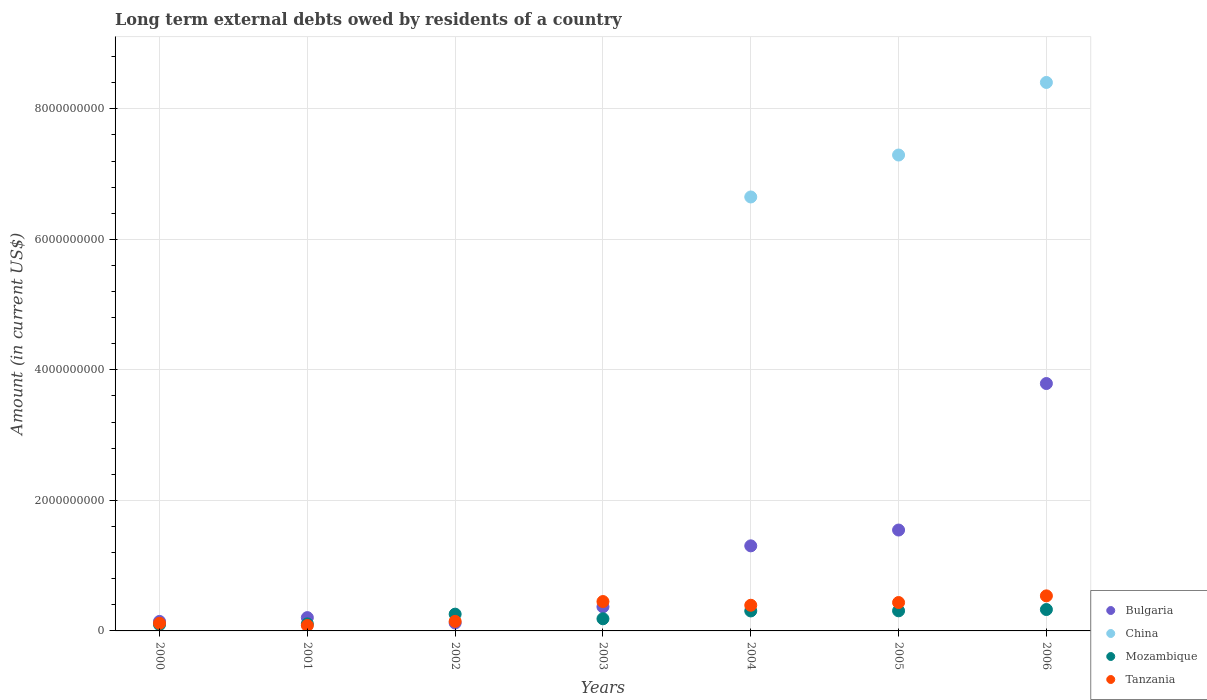How many different coloured dotlines are there?
Offer a terse response. 4. What is the amount of long-term external debts owed by residents in China in 2000?
Give a very brief answer. 0. Across all years, what is the maximum amount of long-term external debts owed by residents in Bulgaria?
Your response must be concise. 3.79e+09. Across all years, what is the minimum amount of long-term external debts owed by residents in Tanzania?
Your answer should be very brief. 8.26e+07. What is the total amount of long-term external debts owed by residents in Tanzania in the graph?
Offer a very short reply. 2.16e+09. What is the difference between the amount of long-term external debts owed by residents in Tanzania in 2002 and that in 2003?
Give a very brief answer. -3.04e+08. What is the difference between the amount of long-term external debts owed by residents in Bulgaria in 2006 and the amount of long-term external debts owed by residents in Mozambique in 2005?
Offer a very short reply. 3.48e+09. What is the average amount of long-term external debts owed by residents in Bulgaria per year?
Your answer should be very brief. 1.07e+09. In the year 2001, what is the difference between the amount of long-term external debts owed by residents in Tanzania and amount of long-term external debts owed by residents in Mozambique?
Your response must be concise. -2.53e+07. What is the ratio of the amount of long-term external debts owed by residents in Bulgaria in 2004 to that in 2006?
Your answer should be very brief. 0.34. What is the difference between the highest and the second highest amount of long-term external debts owed by residents in Tanzania?
Offer a very short reply. 8.70e+07. What is the difference between the highest and the lowest amount of long-term external debts owed by residents in Tanzania?
Provide a succinct answer. 4.55e+08. In how many years, is the amount of long-term external debts owed by residents in Tanzania greater than the average amount of long-term external debts owed by residents in Tanzania taken over all years?
Offer a very short reply. 4. Is the sum of the amount of long-term external debts owed by residents in Mozambique in 2001 and 2005 greater than the maximum amount of long-term external debts owed by residents in Bulgaria across all years?
Offer a terse response. No. Is it the case that in every year, the sum of the amount of long-term external debts owed by residents in Mozambique and amount of long-term external debts owed by residents in Bulgaria  is greater than the sum of amount of long-term external debts owed by residents in China and amount of long-term external debts owed by residents in Tanzania?
Give a very brief answer. No. Is it the case that in every year, the sum of the amount of long-term external debts owed by residents in Bulgaria and amount of long-term external debts owed by residents in Tanzania  is greater than the amount of long-term external debts owed by residents in China?
Provide a succinct answer. No. Is the amount of long-term external debts owed by residents in Mozambique strictly greater than the amount of long-term external debts owed by residents in China over the years?
Your answer should be compact. No. Is the amount of long-term external debts owed by residents in Mozambique strictly less than the amount of long-term external debts owed by residents in Bulgaria over the years?
Your answer should be compact. No. How many dotlines are there?
Your response must be concise. 4. How many years are there in the graph?
Offer a very short reply. 7. What is the difference between two consecutive major ticks on the Y-axis?
Provide a succinct answer. 2.00e+09. How are the legend labels stacked?
Keep it short and to the point. Vertical. What is the title of the graph?
Your answer should be very brief. Long term external debts owed by residents of a country. What is the label or title of the X-axis?
Provide a succinct answer. Years. What is the label or title of the Y-axis?
Make the answer very short. Amount (in current US$). What is the Amount (in current US$) of Bulgaria in 2000?
Make the answer very short. 1.45e+08. What is the Amount (in current US$) in Mozambique in 2000?
Your answer should be compact. 9.69e+07. What is the Amount (in current US$) of Tanzania in 2000?
Your answer should be compact. 1.18e+08. What is the Amount (in current US$) of Bulgaria in 2001?
Your answer should be very brief. 2.04e+08. What is the Amount (in current US$) of China in 2001?
Provide a short and direct response. 0. What is the Amount (in current US$) of Mozambique in 2001?
Make the answer very short. 1.08e+08. What is the Amount (in current US$) of Tanzania in 2001?
Keep it short and to the point. 8.26e+07. What is the Amount (in current US$) in Bulgaria in 2002?
Offer a very short reply. 1.21e+08. What is the Amount (in current US$) of Mozambique in 2002?
Keep it short and to the point. 2.57e+08. What is the Amount (in current US$) in Tanzania in 2002?
Keep it short and to the point. 1.46e+08. What is the Amount (in current US$) of Bulgaria in 2003?
Provide a short and direct response. 3.69e+08. What is the Amount (in current US$) of Mozambique in 2003?
Give a very brief answer. 1.86e+08. What is the Amount (in current US$) of Tanzania in 2003?
Offer a terse response. 4.50e+08. What is the Amount (in current US$) of Bulgaria in 2004?
Your answer should be compact. 1.30e+09. What is the Amount (in current US$) in China in 2004?
Give a very brief answer. 6.65e+09. What is the Amount (in current US$) of Mozambique in 2004?
Keep it short and to the point. 3.06e+08. What is the Amount (in current US$) of Tanzania in 2004?
Provide a short and direct response. 3.93e+08. What is the Amount (in current US$) of Bulgaria in 2005?
Make the answer very short. 1.55e+09. What is the Amount (in current US$) of China in 2005?
Your response must be concise. 7.29e+09. What is the Amount (in current US$) in Mozambique in 2005?
Keep it short and to the point. 3.08e+08. What is the Amount (in current US$) in Tanzania in 2005?
Make the answer very short. 4.35e+08. What is the Amount (in current US$) of Bulgaria in 2006?
Keep it short and to the point. 3.79e+09. What is the Amount (in current US$) of China in 2006?
Provide a short and direct response. 8.40e+09. What is the Amount (in current US$) of Mozambique in 2006?
Provide a short and direct response. 3.28e+08. What is the Amount (in current US$) in Tanzania in 2006?
Offer a terse response. 5.37e+08. Across all years, what is the maximum Amount (in current US$) in Bulgaria?
Keep it short and to the point. 3.79e+09. Across all years, what is the maximum Amount (in current US$) in China?
Your answer should be compact. 8.40e+09. Across all years, what is the maximum Amount (in current US$) in Mozambique?
Provide a succinct answer. 3.28e+08. Across all years, what is the maximum Amount (in current US$) in Tanzania?
Provide a succinct answer. 5.37e+08. Across all years, what is the minimum Amount (in current US$) in Bulgaria?
Offer a very short reply. 1.21e+08. Across all years, what is the minimum Amount (in current US$) of Mozambique?
Offer a terse response. 9.69e+07. Across all years, what is the minimum Amount (in current US$) of Tanzania?
Make the answer very short. 8.26e+07. What is the total Amount (in current US$) in Bulgaria in the graph?
Offer a terse response. 7.48e+09. What is the total Amount (in current US$) of China in the graph?
Ensure brevity in your answer.  2.23e+1. What is the total Amount (in current US$) in Mozambique in the graph?
Provide a short and direct response. 1.59e+09. What is the total Amount (in current US$) of Tanzania in the graph?
Your response must be concise. 2.16e+09. What is the difference between the Amount (in current US$) in Bulgaria in 2000 and that in 2001?
Provide a succinct answer. -5.84e+07. What is the difference between the Amount (in current US$) of Mozambique in 2000 and that in 2001?
Give a very brief answer. -1.10e+07. What is the difference between the Amount (in current US$) in Tanzania in 2000 and that in 2001?
Provide a succinct answer. 3.51e+07. What is the difference between the Amount (in current US$) in Bulgaria in 2000 and that in 2002?
Provide a succinct answer. 2.41e+07. What is the difference between the Amount (in current US$) of Mozambique in 2000 and that in 2002?
Provide a succinct answer. -1.60e+08. What is the difference between the Amount (in current US$) of Tanzania in 2000 and that in 2002?
Offer a terse response. -2.85e+07. What is the difference between the Amount (in current US$) of Bulgaria in 2000 and that in 2003?
Your answer should be compact. -2.24e+08. What is the difference between the Amount (in current US$) in Mozambique in 2000 and that in 2003?
Keep it short and to the point. -8.91e+07. What is the difference between the Amount (in current US$) in Tanzania in 2000 and that in 2003?
Your response must be concise. -3.32e+08. What is the difference between the Amount (in current US$) in Bulgaria in 2000 and that in 2004?
Offer a very short reply. -1.16e+09. What is the difference between the Amount (in current US$) of Mozambique in 2000 and that in 2004?
Offer a terse response. -2.09e+08. What is the difference between the Amount (in current US$) of Tanzania in 2000 and that in 2004?
Give a very brief answer. -2.75e+08. What is the difference between the Amount (in current US$) of Bulgaria in 2000 and that in 2005?
Keep it short and to the point. -1.40e+09. What is the difference between the Amount (in current US$) in Mozambique in 2000 and that in 2005?
Ensure brevity in your answer.  -2.11e+08. What is the difference between the Amount (in current US$) of Tanzania in 2000 and that in 2005?
Keep it short and to the point. -3.17e+08. What is the difference between the Amount (in current US$) of Bulgaria in 2000 and that in 2006?
Ensure brevity in your answer.  -3.65e+09. What is the difference between the Amount (in current US$) of Mozambique in 2000 and that in 2006?
Provide a short and direct response. -2.31e+08. What is the difference between the Amount (in current US$) in Tanzania in 2000 and that in 2006?
Your answer should be very brief. -4.19e+08. What is the difference between the Amount (in current US$) of Bulgaria in 2001 and that in 2002?
Offer a terse response. 8.25e+07. What is the difference between the Amount (in current US$) in Mozambique in 2001 and that in 2002?
Make the answer very short. -1.49e+08. What is the difference between the Amount (in current US$) in Tanzania in 2001 and that in 2002?
Give a very brief answer. -6.37e+07. What is the difference between the Amount (in current US$) of Bulgaria in 2001 and that in 2003?
Provide a succinct answer. -1.66e+08. What is the difference between the Amount (in current US$) in Mozambique in 2001 and that in 2003?
Your answer should be compact. -7.81e+07. What is the difference between the Amount (in current US$) in Tanzania in 2001 and that in 2003?
Make the answer very short. -3.68e+08. What is the difference between the Amount (in current US$) of Bulgaria in 2001 and that in 2004?
Keep it short and to the point. -1.10e+09. What is the difference between the Amount (in current US$) of Mozambique in 2001 and that in 2004?
Your answer should be compact. -1.98e+08. What is the difference between the Amount (in current US$) of Tanzania in 2001 and that in 2004?
Keep it short and to the point. -3.11e+08. What is the difference between the Amount (in current US$) in Bulgaria in 2001 and that in 2005?
Keep it short and to the point. -1.34e+09. What is the difference between the Amount (in current US$) of Mozambique in 2001 and that in 2005?
Your answer should be compact. -2.00e+08. What is the difference between the Amount (in current US$) in Tanzania in 2001 and that in 2005?
Your answer should be very brief. -3.52e+08. What is the difference between the Amount (in current US$) in Bulgaria in 2001 and that in 2006?
Make the answer very short. -3.59e+09. What is the difference between the Amount (in current US$) in Mozambique in 2001 and that in 2006?
Provide a short and direct response. -2.20e+08. What is the difference between the Amount (in current US$) of Tanzania in 2001 and that in 2006?
Make the answer very short. -4.55e+08. What is the difference between the Amount (in current US$) in Bulgaria in 2002 and that in 2003?
Make the answer very short. -2.48e+08. What is the difference between the Amount (in current US$) of Mozambique in 2002 and that in 2003?
Your response must be concise. 7.09e+07. What is the difference between the Amount (in current US$) of Tanzania in 2002 and that in 2003?
Give a very brief answer. -3.04e+08. What is the difference between the Amount (in current US$) of Bulgaria in 2002 and that in 2004?
Your answer should be compact. -1.18e+09. What is the difference between the Amount (in current US$) in Mozambique in 2002 and that in 2004?
Give a very brief answer. -4.92e+07. What is the difference between the Amount (in current US$) in Tanzania in 2002 and that in 2004?
Provide a short and direct response. -2.47e+08. What is the difference between the Amount (in current US$) of Bulgaria in 2002 and that in 2005?
Your answer should be compact. -1.42e+09. What is the difference between the Amount (in current US$) in Mozambique in 2002 and that in 2005?
Ensure brevity in your answer.  -5.10e+07. What is the difference between the Amount (in current US$) in Tanzania in 2002 and that in 2005?
Your answer should be very brief. -2.89e+08. What is the difference between the Amount (in current US$) of Bulgaria in 2002 and that in 2006?
Your response must be concise. -3.67e+09. What is the difference between the Amount (in current US$) of Mozambique in 2002 and that in 2006?
Your answer should be compact. -7.09e+07. What is the difference between the Amount (in current US$) in Tanzania in 2002 and that in 2006?
Offer a terse response. -3.91e+08. What is the difference between the Amount (in current US$) in Bulgaria in 2003 and that in 2004?
Keep it short and to the point. -9.34e+08. What is the difference between the Amount (in current US$) of Mozambique in 2003 and that in 2004?
Ensure brevity in your answer.  -1.20e+08. What is the difference between the Amount (in current US$) in Tanzania in 2003 and that in 2004?
Keep it short and to the point. 5.70e+07. What is the difference between the Amount (in current US$) of Bulgaria in 2003 and that in 2005?
Give a very brief answer. -1.18e+09. What is the difference between the Amount (in current US$) of Mozambique in 2003 and that in 2005?
Your answer should be very brief. -1.22e+08. What is the difference between the Amount (in current US$) of Tanzania in 2003 and that in 2005?
Your response must be concise. 1.50e+07. What is the difference between the Amount (in current US$) of Bulgaria in 2003 and that in 2006?
Your answer should be compact. -3.42e+09. What is the difference between the Amount (in current US$) in Mozambique in 2003 and that in 2006?
Make the answer very short. -1.42e+08. What is the difference between the Amount (in current US$) in Tanzania in 2003 and that in 2006?
Ensure brevity in your answer.  -8.70e+07. What is the difference between the Amount (in current US$) of Bulgaria in 2004 and that in 2005?
Offer a terse response. -2.42e+08. What is the difference between the Amount (in current US$) in China in 2004 and that in 2005?
Keep it short and to the point. -6.43e+08. What is the difference between the Amount (in current US$) of Mozambique in 2004 and that in 2005?
Your answer should be compact. -1.89e+06. What is the difference between the Amount (in current US$) in Tanzania in 2004 and that in 2005?
Provide a short and direct response. -4.20e+07. What is the difference between the Amount (in current US$) of Bulgaria in 2004 and that in 2006?
Make the answer very short. -2.49e+09. What is the difference between the Amount (in current US$) in China in 2004 and that in 2006?
Make the answer very short. -1.75e+09. What is the difference between the Amount (in current US$) in Mozambique in 2004 and that in 2006?
Give a very brief answer. -2.17e+07. What is the difference between the Amount (in current US$) of Tanzania in 2004 and that in 2006?
Give a very brief answer. -1.44e+08. What is the difference between the Amount (in current US$) in Bulgaria in 2005 and that in 2006?
Give a very brief answer. -2.24e+09. What is the difference between the Amount (in current US$) in China in 2005 and that in 2006?
Offer a very short reply. -1.11e+09. What is the difference between the Amount (in current US$) of Mozambique in 2005 and that in 2006?
Make the answer very short. -1.98e+07. What is the difference between the Amount (in current US$) of Tanzania in 2005 and that in 2006?
Give a very brief answer. -1.02e+08. What is the difference between the Amount (in current US$) of Bulgaria in 2000 and the Amount (in current US$) of Mozambique in 2001?
Keep it short and to the point. 3.75e+07. What is the difference between the Amount (in current US$) of Bulgaria in 2000 and the Amount (in current US$) of Tanzania in 2001?
Offer a very short reply. 6.28e+07. What is the difference between the Amount (in current US$) in Mozambique in 2000 and the Amount (in current US$) in Tanzania in 2001?
Offer a very short reply. 1.43e+07. What is the difference between the Amount (in current US$) of Bulgaria in 2000 and the Amount (in current US$) of Mozambique in 2002?
Ensure brevity in your answer.  -1.12e+08. What is the difference between the Amount (in current US$) in Bulgaria in 2000 and the Amount (in current US$) in Tanzania in 2002?
Give a very brief answer. -8.78e+05. What is the difference between the Amount (in current US$) in Mozambique in 2000 and the Amount (in current US$) in Tanzania in 2002?
Offer a terse response. -4.94e+07. What is the difference between the Amount (in current US$) of Bulgaria in 2000 and the Amount (in current US$) of Mozambique in 2003?
Offer a very short reply. -4.06e+07. What is the difference between the Amount (in current US$) in Bulgaria in 2000 and the Amount (in current US$) in Tanzania in 2003?
Provide a short and direct response. -3.05e+08. What is the difference between the Amount (in current US$) in Mozambique in 2000 and the Amount (in current US$) in Tanzania in 2003?
Your answer should be compact. -3.53e+08. What is the difference between the Amount (in current US$) of Bulgaria in 2000 and the Amount (in current US$) of China in 2004?
Your response must be concise. -6.50e+09. What is the difference between the Amount (in current US$) of Bulgaria in 2000 and the Amount (in current US$) of Mozambique in 2004?
Make the answer very short. -1.61e+08. What is the difference between the Amount (in current US$) of Bulgaria in 2000 and the Amount (in current US$) of Tanzania in 2004?
Your answer should be very brief. -2.48e+08. What is the difference between the Amount (in current US$) of Mozambique in 2000 and the Amount (in current US$) of Tanzania in 2004?
Provide a succinct answer. -2.96e+08. What is the difference between the Amount (in current US$) in Bulgaria in 2000 and the Amount (in current US$) in China in 2005?
Offer a terse response. -7.15e+09. What is the difference between the Amount (in current US$) in Bulgaria in 2000 and the Amount (in current US$) in Mozambique in 2005?
Make the answer very short. -1.63e+08. What is the difference between the Amount (in current US$) of Bulgaria in 2000 and the Amount (in current US$) of Tanzania in 2005?
Ensure brevity in your answer.  -2.90e+08. What is the difference between the Amount (in current US$) of Mozambique in 2000 and the Amount (in current US$) of Tanzania in 2005?
Make the answer very short. -3.38e+08. What is the difference between the Amount (in current US$) of Bulgaria in 2000 and the Amount (in current US$) of China in 2006?
Provide a short and direct response. -8.26e+09. What is the difference between the Amount (in current US$) of Bulgaria in 2000 and the Amount (in current US$) of Mozambique in 2006?
Make the answer very short. -1.82e+08. What is the difference between the Amount (in current US$) in Bulgaria in 2000 and the Amount (in current US$) in Tanzania in 2006?
Make the answer very short. -3.92e+08. What is the difference between the Amount (in current US$) of Mozambique in 2000 and the Amount (in current US$) of Tanzania in 2006?
Your response must be concise. -4.40e+08. What is the difference between the Amount (in current US$) in Bulgaria in 2001 and the Amount (in current US$) in Mozambique in 2002?
Give a very brief answer. -5.31e+07. What is the difference between the Amount (in current US$) of Bulgaria in 2001 and the Amount (in current US$) of Tanzania in 2002?
Your answer should be very brief. 5.75e+07. What is the difference between the Amount (in current US$) of Mozambique in 2001 and the Amount (in current US$) of Tanzania in 2002?
Offer a terse response. -3.84e+07. What is the difference between the Amount (in current US$) in Bulgaria in 2001 and the Amount (in current US$) in Mozambique in 2003?
Ensure brevity in your answer.  1.78e+07. What is the difference between the Amount (in current US$) in Bulgaria in 2001 and the Amount (in current US$) in Tanzania in 2003?
Offer a terse response. -2.46e+08. What is the difference between the Amount (in current US$) in Mozambique in 2001 and the Amount (in current US$) in Tanzania in 2003?
Keep it short and to the point. -3.42e+08. What is the difference between the Amount (in current US$) in Bulgaria in 2001 and the Amount (in current US$) in China in 2004?
Provide a short and direct response. -6.45e+09. What is the difference between the Amount (in current US$) of Bulgaria in 2001 and the Amount (in current US$) of Mozambique in 2004?
Ensure brevity in your answer.  -1.02e+08. What is the difference between the Amount (in current US$) of Bulgaria in 2001 and the Amount (in current US$) of Tanzania in 2004?
Make the answer very short. -1.89e+08. What is the difference between the Amount (in current US$) of Mozambique in 2001 and the Amount (in current US$) of Tanzania in 2004?
Ensure brevity in your answer.  -2.85e+08. What is the difference between the Amount (in current US$) of Bulgaria in 2001 and the Amount (in current US$) of China in 2005?
Provide a succinct answer. -7.09e+09. What is the difference between the Amount (in current US$) in Bulgaria in 2001 and the Amount (in current US$) in Mozambique in 2005?
Provide a short and direct response. -1.04e+08. What is the difference between the Amount (in current US$) in Bulgaria in 2001 and the Amount (in current US$) in Tanzania in 2005?
Make the answer very short. -2.31e+08. What is the difference between the Amount (in current US$) of Mozambique in 2001 and the Amount (in current US$) of Tanzania in 2005?
Provide a succinct answer. -3.27e+08. What is the difference between the Amount (in current US$) of Bulgaria in 2001 and the Amount (in current US$) of China in 2006?
Offer a very short reply. -8.20e+09. What is the difference between the Amount (in current US$) of Bulgaria in 2001 and the Amount (in current US$) of Mozambique in 2006?
Keep it short and to the point. -1.24e+08. What is the difference between the Amount (in current US$) in Bulgaria in 2001 and the Amount (in current US$) in Tanzania in 2006?
Provide a short and direct response. -3.33e+08. What is the difference between the Amount (in current US$) in Mozambique in 2001 and the Amount (in current US$) in Tanzania in 2006?
Offer a very short reply. -4.29e+08. What is the difference between the Amount (in current US$) in Bulgaria in 2002 and the Amount (in current US$) in Mozambique in 2003?
Make the answer very short. -6.47e+07. What is the difference between the Amount (in current US$) of Bulgaria in 2002 and the Amount (in current US$) of Tanzania in 2003?
Your response must be concise. -3.29e+08. What is the difference between the Amount (in current US$) in Mozambique in 2002 and the Amount (in current US$) in Tanzania in 2003?
Ensure brevity in your answer.  -1.93e+08. What is the difference between the Amount (in current US$) of Bulgaria in 2002 and the Amount (in current US$) of China in 2004?
Give a very brief answer. -6.53e+09. What is the difference between the Amount (in current US$) in Bulgaria in 2002 and the Amount (in current US$) in Mozambique in 2004?
Keep it short and to the point. -1.85e+08. What is the difference between the Amount (in current US$) in Bulgaria in 2002 and the Amount (in current US$) in Tanzania in 2004?
Your answer should be compact. -2.72e+08. What is the difference between the Amount (in current US$) of Mozambique in 2002 and the Amount (in current US$) of Tanzania in 2004?
Give a very brief answer. -1.36e+08. What is the difference between the Amount (in current US$) in Bulgaria in 2002 and the Amount (in current US$) in China in 2005?
Provide a succinct answer. -7.17e+09. What is the difference between the Amount (in current US$) in Bulgaria in 2002 and the Amount (in current US$) in Mozambique in 2005?
Provide a succinct answer. -1.87e+08. What is the difference between the Amount (in current US$) in Bulgaria in 2002 and the Amount (in current US$) in Tanzania in 2005?
Make the answer very short. -3.14e+08. What is the difference between the Amount (in current US$) in Mozambique in 2002 and the Amount (in current US$) in Tanzania in 2005?
Offer a very short reply. -1.78e+08. What is the difference between the Amount (in current US$) in Bulgaria in 2002 and the Amount (in current US$) in China in 2006?
Make the answer very short. -8.28e+09. What is the difference between the Amount (in current US$) in Bulgaria in 2002 and the Amount (in current US$) in Mozambique in 2006?
Offer a very short reply. -2.07e+08. What is the difference between the Amount (in current US$) of Bulgaria in 2002 and the Amount (in current US$) of Tanzania in 2006?
Your response must be concise. -4.16e+08. What is the difference between the Amount (in current US$) in Mozambique in 2002 and the Amount (in current US$) in Tanzania in 2006?
Keep it short and to the point. -2.80e+08. What is the difference between the Amount (in current US$) in Bulgaria in 2003 and the Amount (in current US$) in China in 2004?
Your answer should be very brief. -6.28e+09. What is the difference between the Amount (in current US$) of Bulgaria in 2003 and the Amount (in current US$) of Mozambique in 2004?
Your response must be concise. 6.32e+07. What is the difference between the Amount (in current US$) of Bulgaria in 2003 and the Amount (in current US$) of Tanzania in 2004?
Keep it short and to the point. -2.38e+07. What is the difference between the Amount (in current US$) in Mozambique in 2003 and the Amount (in current US$) in Tanzania in 2004?
Your answer should be very brief. -2.07e+08. What is the difference between the Amount (in current US$) of Bulgaria in 2003 and the Amount (in current US$) of China in 2005?
Your answer should be compact. -6.92e+09. What is the difference between the Amount (in current US$) in Bulgaria in 2003 and the Amount (in current US$) in Mozambique in 2005?
Make the answer very short. 6.13e+07. What is the difference between the Amount (in current US$) in Bulgaria in 2003 and the Amount (in current US$) in Tanzania in 2005?
Your response must be concise. -6.58e+07. What is the difference between the Amount (in current US$) of Mozambique in 2003 and the Amount (in current US$) of Tanzania in 2005?
Keep it short and to the point. -2.49e+08. What is the difference between the Amount (in current US$) in Bulgaria in 2003 and the Amount (in current US$) in China in 2006?
Give a very brief answer. -8.03e+09. What is the difference between the Amount (in current US$) of Bulgaria in 2003 and the Amount (in current US$) of Mozambique in 2006?
Your answer should be compact. 4.15e+07. What is the difference between the Amount (in current US$) of Bulgaria in 2003 and the Amount (in current US$) of Tanzania in 2006?
Offer a very short reply. -1.68e+08. What is the difference between the Amount (in current US$) of Mozambique in 2003 and the Amount (in current US$) of Tanzania in 2006?
Your answer should be very brief. -3.51e+08. What is the difference between the Amount (in current US$) in Bulgaria in 2004 and the Amount (in current US$) in China in 2005?
Offer a very short reply. -5.99e+09. What is the difference between the Amount (in current US$) of Bulgaria in 2004 and the Amount (in current US$) of Mozambique in 2005?
Ensure brevity in your answer.  9.95e+08. What is the difference between the Amount (in current US$) of Bulgaria in 2004 and the Amount (in current US$) of Tanzania in 2005?
Provide a short and direct response. 8.68e+08. What is the difference between the Amount (in current US$) in China in 2004 and the Amount (in current US$) in Mozambique in 2005?
Make the answer very short. 6.34e+09. What is the difference between the Amount (in current US$) of China in 2004 and the Amount (in current US$) of Tanzania in 2005?
Offer a terse response. 6.21e+09. What is the difference between the Amount (in current US$) in Mozambique in 2004 and the Amount (in current US$) in Tanzania in 2005?
Your response must be concise. -1.29e+08. What is the difference between the Amount (in current US$) in Bulgaria in 2004 and the Amount (in current US$) in China in 2006?
Offer a very short reply. -7.10e+09. What is the difference between the Amount (in current US$) of Bulgaria in 2004 and the Amount (in current US$) of Mozambique in 2006?
Offer a very short reply. 9.76e+08. What is the difference between the Amount (in current US$) in Bulgaria in 2004 and the Amount (in current US$) in Tanzania in 2006?
Your answer should be compact. 7.66e+08. What is the difference between the Amount (in current US$) of China in 2004 and the Amount (in current US$) of Mozambique in 2006?
Give a very brief answer. 6.32e+09. What is the difference between the Amount (in current US$) of China in 2004 and the Amount (in current US$) of Tanzania in 2006?
Your response must be concise. 6.11e+09. What is the difference between the Amount (in current US$) of Mozambique in 2004 and the Amount (in current US$) of Tanzania in 2006?
Ensure brevity in your answer.  -2.31e+08. What is the difference between the Amount (in current US$) in Bulgaria in 2005 and the Amount (in current US$) in China in 2006?
Your answer should be very brief. -6.86e+09. What is the difference between the Amount (in current US$) of Bulgaria in 2005 and the Amount (in current US$) of Mozambique in 2006?
Keep it short and to the point. 1.22e+09. What is the difference between the Amount (in current US$) of Bulgaria in 2005 and the Amount (in current US$) of Tanzania in 2006?
Provide a short and direct response. 1.01e+09. What is the difference between the Amount (in current US$) in China in 2005 and the Amount (in current US$) in Mozambique in 2006?
Your response must be concise. 6.96e+09. What is the difference between the Amount (in current US$) of China in 2005 and the Amount (in current US$) of Tanzania in 2006?
Offer a terse response. 6.75e+09. What is the difference between the Amount (in current US$) in Mozambique in 2005 and the Amount (in current US$) in Tanzania in 2006?
Provide a succinct answer. -2.29e+08. What is the average Amount (in current US$) in Bulgaria per year?
Make the answer very short. 1.07e+09. What is the average Amount (in current US$) of China per year?
Make the answer very short. 3.19e+09. What is the average Amount (in current US$) in Mozambique per year?
Give a very brief answer. 2.27e+08. What is the average Amount (in current US$) of Tanzania per year?
Make the answer very short. 3.09e+08. In the year 2000, what is the difference between the Amount (in current US$) in Bulgaria and Amount (in current US$) in Mozambique?
Keep it short and to the point. 4.85e+07. In the year 2000, what is the difference between the Amount (in current US$) in Bulgaria and Amount (in current US$) in Tanzania?
Your answer should be compact. 2.77e+07. In the year 2000, what is the difference between the Amount (in current US$) of Mozambique and Amount (in current US$) of Tanzania?
Keep it short and to the point. -2.08e+07. In the year 2001, what is the difference between the Amount (in current US$) in Bulgaria and Amount (in current US$) in Mozambique?
Ensure brevity in your answer.  9.59e+07. In the year 2001, what is the difference between the Amount (in current US$) in Bulgaria and Amount (in current US$) in Tanzania?
Provide a short and direct response. 1.21e+08. In the year 2001, what is the difference between the Amount (in current US$) in Mozambique and Amount (in current US$) in Tanzania?
Keep it short and to the point. 2.53e+07. In the year 2002, what is the difference between the Amount (in current US$) in Bulgaria and Amount (in current US$) in Mozambique?
Your response must be concise. -1.36e+08. In the year 2002, what is the difference between the Amount (in current US$) of Bulgaria and Amount (in current US$) of Tanzania?
Ensure brevity in your answer.  -2.50e+07. In the year 2002, what is the difference between the Amount (in current US$) in Mozambique and Amount (in current US$) in Tanzania?
Provide a short and direct response. 1.11e+08. In the year 2003, what is the difference between the Amount (in current US$) in Bulgaria and Amount (in current US$) in Mozambique?
Provide a short and direct response. 1.83e+08. In the year 2003, what is the difference between the Amount (in current US$) in Bulgaria and Amount (in current US$) in Tanzania?
Ensure brevity in your answer.  -8.08e+07. In the year 2003, what is the difference between the Amount (in current US$) of Mozambique and Amount (in current US$) of Tanzania?
Offer a terse response. -2.64e+08. In the year 2004, what is the difference between the Amount (in current US$) in Bulgaria and Amount (in current US$) in China?
Give a very brief answer. -5.35e+09. In the year 2004, what is the difference between the Amount (in current US$) in Bulgaria and Amount (in current US$) in Mozambique?
Give a very brief answer. 9.97e+08. In the year 2004, what is the difference between the Amount (in current US$) of Bulgaria and Amount (in current US$) of Tanzania?
Offer a terse response. 9.10e+08. In the year 2004, what is the difference between the Amount (in current US$) in China and Amount (in current US$) in Mozambique?
Keep it short and to the point. 6.34e+09. In the year 2004, what is the difference between the Amount (in current US$) in China and Amount (in current US$) in Tanzania?
Provide a succinct answer. 6.26e+09. In the year 2004, what is the difference between the Amount (in current US$) in Mozambique and Amount (in current US$) in Tanzania?
Your answer should be compact. -8.70e+07. In the year 2005, what is the difference between the Amount (in current US$) of Bulgaria and Amount (in current US$) of China?
Your response must be concise. -5.75e+09. In the year 2005, what is the difference between the Amount (in current US$) of Bulgaria and Amount (in current US$) of Mozambique?
Your answer should be very brief. 1.24e+09. In the year 2005, what is the difference between the Amount (in current US$) in Bulgaria and Amount (in current US$) in Tanzania?
Your answer should be very brief. 1.11e+09. In the year 2005, what is the difference between the Amount (in current US$) of China and Amount (in current US$) of Mozambique?
Give a very brief answer. 6.98e+09. In the year 2005, what is the difference between the Amount (in current US$) in China and Amount (in current US$) in Tanzania?
Your answer should be very brief. 6.86e+09. In the year 2005, what is the difference between the Amount (in current US$) in Mozambique and Amount (in current US$) in Tanzania?
Give a very brief answer. -1.27e+08. In the year 2006, what is the difference between the Amount (in current US$) in Bulgaria and Amount (in current US$) in China?
Your answer should be compact. -4.61e+09. In the year 2006, what is the difference between the Amount (in current US$) in Bulgaria and Amount (in current US$) in Mozambique?
Offer a terse response. 3.46e+09. In the year 2006, what is the difference between the Amount (in current US$) of Bulgaria and Amount (in current US$) of Tanzania?
Your response must be concise. 3.25e+09. In the year 2006, what is the difference between the Amount (in current US$) of China and Amount (in current US$) of Mozambique?
Provide a short and direct response. 8.08e+09. In the year 2006, what is the difference between the Amount (in current US$) in China and Amount (in current US$) in Tanzania?
Ensure brevity in your answer.  7.87e+09. In the year 2006, what is the difference between the Amount (in current US$) of Mozambique and Amount (in current US$) of Tanzania?
Offer a terse response. -2.09e+08. What is the ratio of the Amount (in current US$) of Bulgaria in 2000 to that in 2001?
Offer a very short reply. 0.71. What is the ratio of the Amount (in current US$) of Mozambique in 2000 to that in 2001?
Keep it short and to the point. 0.9. What is the ratio of the Amount (in current US$) in Tanzania in 2000 to that in 2001?
Make the answer very short. 1.43. What is the ratio of the Amount (in current US$) in Bulgaria in 2000 to that in 2002?
Ensure brevity in your answer.  1.2. What is the ratio of the Amount (in current US$) in Mozambique in 2000 to that in 2002?
Your answer should be very brief. 0.38. What is the ratio of the Amount (in current US$) of Tanzania in 2000 to that in 2002?
Make the answer very short. 0.8. What is the ratio of the Amount (in current US$) of Bulgaria in 2000 to that in 2003?
Offer a terse response. 0.39. What is the ratio of the Amount (in current US$) in Mozambique in 2000 to that in 2003?
Offer a very short reply. 0.52. What is the ratio of the Amount (in current US$) in Tanzania in 2000 to that in 2003?
Your response must be concise. 0.26. What is the ratio of the Amount (in current US$) of Bulgaria in 2000 to that in 2004?
Provide a succinct answer. 0.11. What is the ratio of the Amount (in current US$) of Mozambique in 2000 to that in 2004?
Offer a terse response. 0.32. What is the ratio of the Amount (in current US$) in Tanzania in 2000 to that in 2004?
Make the answer very short. 0.3. What is the ratio of the Amount (in current US$) of Bulgaria in 2000 to that in 2005?
Give a very brief answer. 0.09. What is the ratio of the Amount (in current US$) of Mozambique in 2000 to that in 2005?
Give a very brief answer. 0.31. What is the ratio of the Amount (in current US$) of Tanzania in 2000 to that in 2005?
Make the answer very short. 0.27. What is the ratio of the Amount (in current US$) in Bulgaria in 2000 to that in 2006?
Offer a very short reply. 0.04. What is the ratio of the Amount (in current US$) in Mozambique in 2000 to that in 2006?
Ensure brevity in your answer.  0.3. What is the ratio of the Amount (in current US$) of Tanzania in 2000 to that in 2006?
Make the answer very short. 0.22. What is the ratio of the Amount (in current US$) of Bulgaria in 2001 to that in 2002?
Give a very brief answer. 1.68. What is the ratio of the Amount (in current US$) in Mozambique in 2001 to that in 2002?
Offer a terse response. 0.42. What is the ratio of the Amount (in current US$) of Tanzania in 2001 to that in 2002?
Your answer should be very brief. 0.56. What is the ratio of the Amount (in current US$) of Bulgaria in 2001 to that in 2003?
Your answer should be compact. 0.55. What is the ratio of the Amount (in current US$) of Mozambique in 2001 to that in 2003?
Give a very brief answer. 0.58. What is the ratio of the Amount (in current US$) of Tanzania in 2001 to that in 2003?
Your response must be concise. 0.18. What is the ratio of the Amount (in current US$) in Bulgaria in 2001 to that in 2004?
Your answer should be very brief. 0.16. What is the ratio of the Amount (in current US$) of Mozambique in 2001 to that in 2004?
Offer a terse response. 0.35. What is the ratio of the Amount (in current US$) of Tanzania in 2001 to that in 2004?
Your response must be concise. 0.21. What is the ratio of the Amount (in current US$) in Bulgaria in 2001 to that in 2005?
Provide a succinct answer. 0.13. What is the ratio of the Amount (in current US$) of Mozambique in 2001 to that in 2005?
Make the answer very short. 0.35. What is the ratio of the Amount (in current US$) of Tanzania in 2001 to that in 2005?
Offer a terse response. 0.19. What is the ratio of the Amount (in current US$) in Bulgaria in 2001 to that in 2006?
Make the answer very short. 0.05. What is the ratio of the Amount (in current US$) in Mozambique in 2001 to that in 2006?
Provide a succinct answer. 0.33. What is the ratio of the Amount (in current US$) in Tanzania in 2001 to that in 2006?
Provide a succinct answer. 0.15. What is the ratio of the Amount (in current US$) of Bulgaria in 2002 to that in 2003?
Your response must be concise. 0.33. What is the ratio of the Amount (in current US$) of Mozambique in 2002 to that in 2003?
Your answer should be very brief. 1.38. What is the ratio of the Amount (in current US$) in Tanzania in 2002 to that in 2003?
Provide a succinct answer. 0.33. What is the ratio of the Amount (in current US$) in Bulgaria in 2002 to that in 2004?
Your answer should be compact. 0.09. What is the ratio of the Amount (in current US$) in Mozambique in 2002 to that in 2004?
Provide a short and direct response. 0.84. What is the ratio of the Amount (in current US$) in Tanzania in 2002 to that in 2004?
Ensure brevity in your answer.  0.37. What is the ratio of the Amount (in current US$) in Bulgaria in 2002 to that in 2005?
Ensure brevity in your answer.  0.08. What is the ratio of the Amount (in current US$) of Mozambique in 2002 to that in 2005?
Your answer should be compact. 0.83. What is the ratio of the Amount (in current US$) in Tanzania in 2002 to that in 2005?
Offer a terse response. 0.34. What is the ratio of the Amount (in current US$) of Bulgaria in 2002 to that in 2006?
Provide a succinct answer. 0.03. What is the ratio of the Amount (in current US$) of Mozambique in 2002 to that in 2006?
Provide a succinct answer. 0.78. What is the ratio of the Amount (in current US$) in Tanzania in 2002 to that in 2006?
Ensure brevity in your answer.  0.27. What is the ratio of the Amount (in current US$) in Bulgaria in 2003 to that in 2004?
Your answer should be compact. 0.28. What is the ratio of the Amount (in current US$) in Mozambique in 2003 to that in 2004?
Your answer should be very brief. 0.61. What is the ratio of the Amount (in current US$) in Tanzania in 2003 to that in 2004?
Ensure brevity in your answer.  1.15. What is the ratio of the Amount (in current US$) in Bulgaria in 2003 to that in 2005?
Give a very brief answer. 0.24. What is the ratio of the Amount (in current US$) of Mozambique in 2003 to that in 2005?
Provide a short and direct response. 0.6. What is the ratio of the Amount (in current US$) in Tanzania in 2003 to that in 2005?
Provide a short and direct response. 1.03. What is the ratio of the Amount (in current US$) in Bulgaria in 2003 to that in 2006?
Provide a succinct answer. 0.1. What is the ratio of the Amount (in current US$) in Mozambique in 2003 to that in 2006?
Your answer should be compact. 0.57. What is the ratio of the Amount (in current US$) of Tanzania in 2003 to that in 2006?
Keep it short and to the point. 0.84. What is the ratio of the Amount (in current US$) of Bulgaria in 2004 to that in 2005?
Make the answer very short. 0.84. What is the ratio of the Amount (in current US$) of China in 2004 to that in 2005?
Give a very brief answer. 0.91. What is the ratio of the Amount (in current US$) of Tanzania in 2004 to that in 2005?
Provide a short and direct response. 0.9. What is the ratio of the Amount (in current US$) of Bulgaria in 2004 to that in 2006?
Give a very brief answer. 0.34. What is the ratio of the Amount (in current US$) of China in 2004 to that in 2006?
Provide a short and direct response. 0.79. What is the ratio of the Amount (in current US$) in Mozambique in 2004 to that in 2006?
Your answer should be very brief. 0.93. What is the ratio of the Amount (in current US$) of Tanzania in 2004 to that in 2006?
Ensure brevity in your answer.  0.73. What is the ratio of the Amount (in current US$) in Bulgaria in 2005 to that in 2006?
Your answer should be very brief. 0.41. What is the ratio of the Amount (in current US$) in China in 2005 to that in 2006?
Offer a terse response. 0.87. What is the ratio of the Amount (in current US$) of Mozambique in 2005 to that in 2006?
Your answer should be very brief. 0.94. What is the ratio of the Amount (in current US$) in Tanzania in 2005 to that in 2006?
Offer a terse response. 0.81. What is the difference between the highest and the second highest Amount (in current US$) of Bulgaria?
Offer a terse response. 2.24e+09. What is the difference between the highest and the second highest Amount (in current US$) in China?
Offer a terse response. 1.11e+09. What is the difference between the highest and the second highest Amount (in current US$) of Mozambique?
Your answer should be compact. 1.98e+07. What is the difference between the highest and the second highest Amount (in current US$) of Tanzania?
Make the answer very short. 8.70e+07. What is the difference between the highest and the lowest Amount (in current US$) of Bulgaria?
Offer a terse response. 3.67e+09. What is the difference between the highest and the lowest Amount (in current US$) of China?
Provide a succinct answer. 8.40e+09. What is the difference between the highest and the lowest Amount (in current US$) in Mozambique?
Your answer should be very brief. 2.31e+08. What is the difference between the highest and the lowest Amount (in current US$) of Tanzania?
Give a very brief answer. 4.55e+08. 